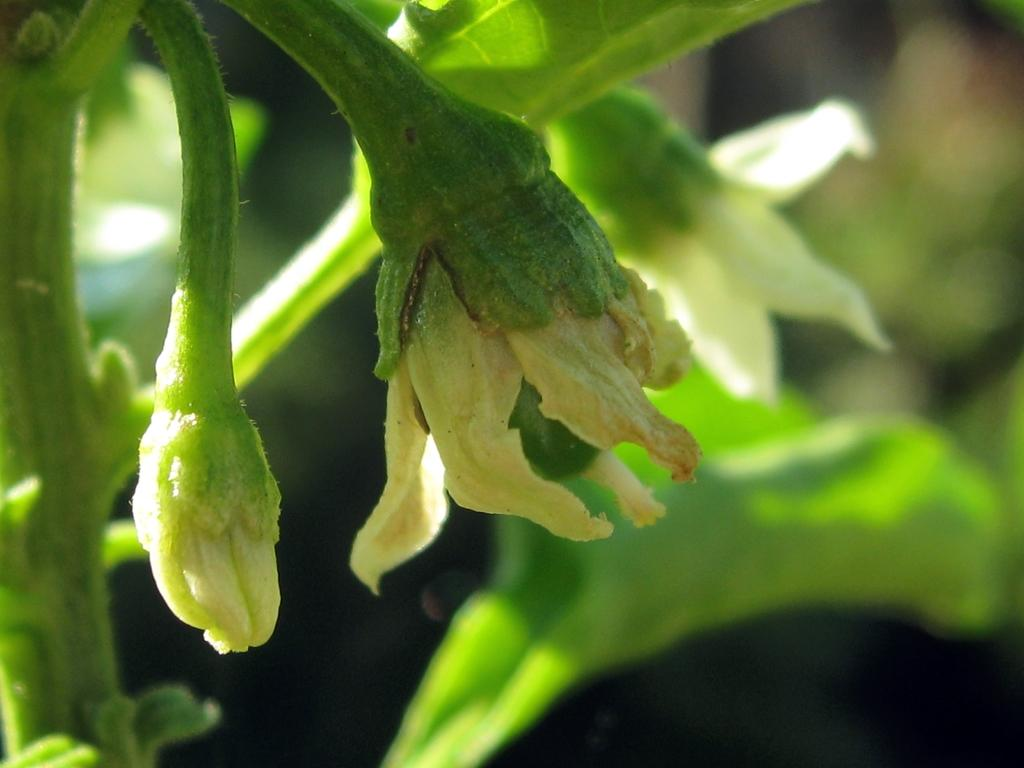What type of plants can be seen in the image? There are flowers and leaves in the image. Can you describe the background of the image? The background of the image is blurry. What type of wax is being applied to the flowers in the image? There is no wax being applied to the flowers in the image; it is a photograph of flowers and leaves. 